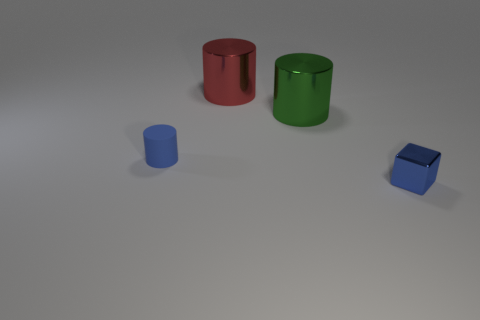Subtract all tiny cylinders. How many cylinders are left? 2 Add 1 large yellow blocks. How many objects exist? 5 Subtract all red cylinders. How many cylinders are left? 2 Subtract all cylinders. How many objects are left? 1 Add 2 tiny blue cylinders. How many tiny blue cylinders are left? 3 Add 1 small blue metal balls. How many small blue metal balls exist? 1 Subtract 0 yellow cubes. How many objects are left? 4 Subtract all brown blocks. Subtract all gray cylinders. How many blocks are left? 1 Subtract all small red cubes. Subtract all rubber objects. How many objects are left? 3 